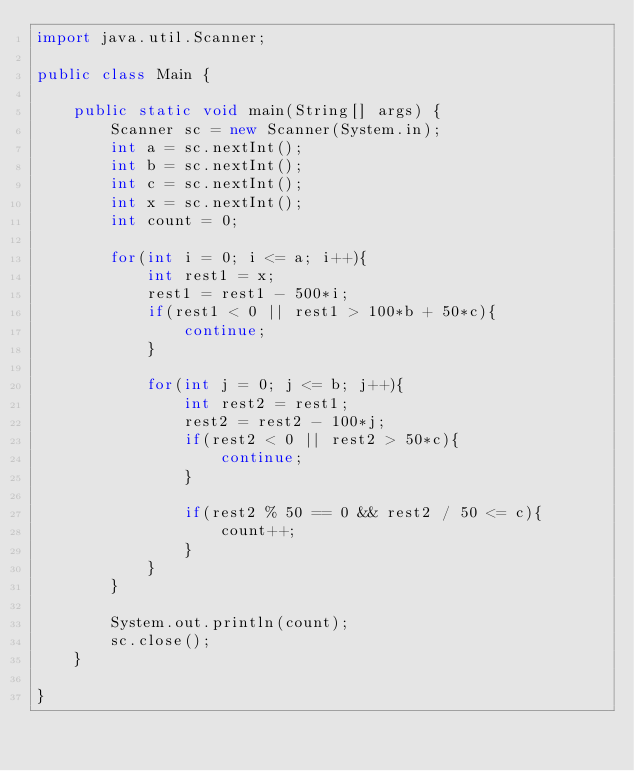Convert code to text. <code><loc_0><loc_0><loc_500><loc_500><_Java_>import java.util.Scanner;

public class Main {

    public static void main(String[] args) {
        Scanner sc = new Scanner(System.in);
        int a = sc.nextInt();
        int b = sc.nextInt();
        int c = sc.nextInt();
        int x = sc.nextInt();
        int count = 0;

        for(int i = 0; i <= a; i++){
            int rest1 = x;
            rest1 = rest1 - 500*i;
            if(rest1 < 0 || rest1 > 100*b + 50*c){
                continue;
            }

            for(int j = 0; j <= b; j++){
                int rest2 = rest1;
                rest2 = rest2 - 100*j;
                if(rest2 < 0 || rest2 > 50*c){
                    continue;
                }

                if(rest2 % 50 == 0 && rest2 / 50 <= c){
                    count++;
                }
            }
        }

        System.out.println(count);
        sc.close();
    }

}
</code> 